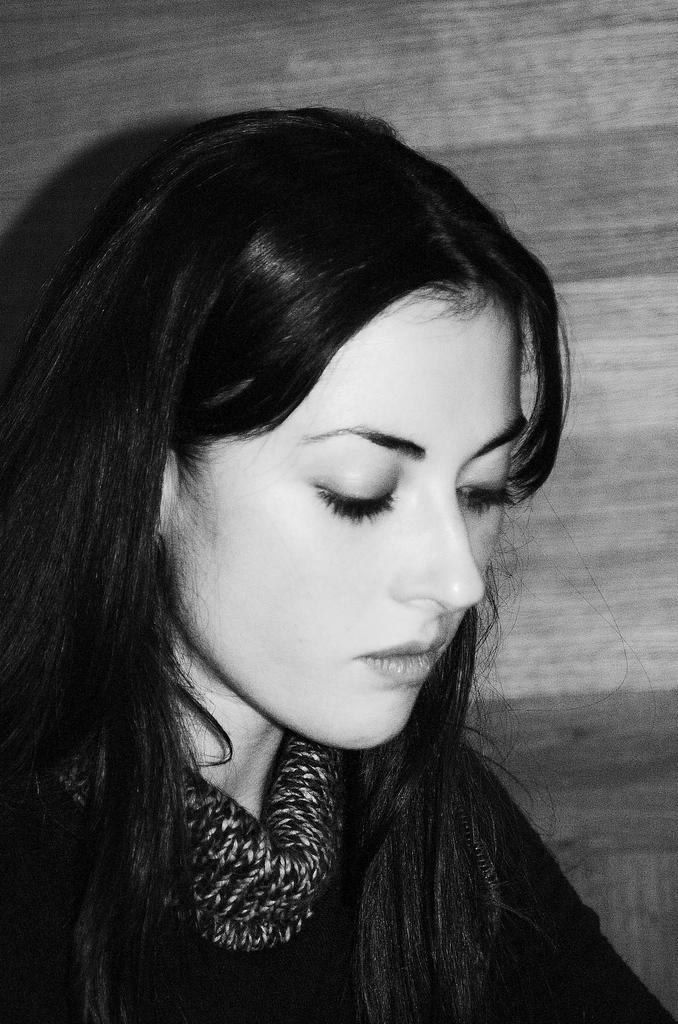What is the color scheme of the image? The image is black and white. Can you describe the main subject in the image? There is a lady in the image. What can be seen in the background of the image? There is a wall in the background of the image. How many geese are visible in the image? There are no geese present in the image. What type of bun is the lady holding in the image? There is no bun visible in the image. 